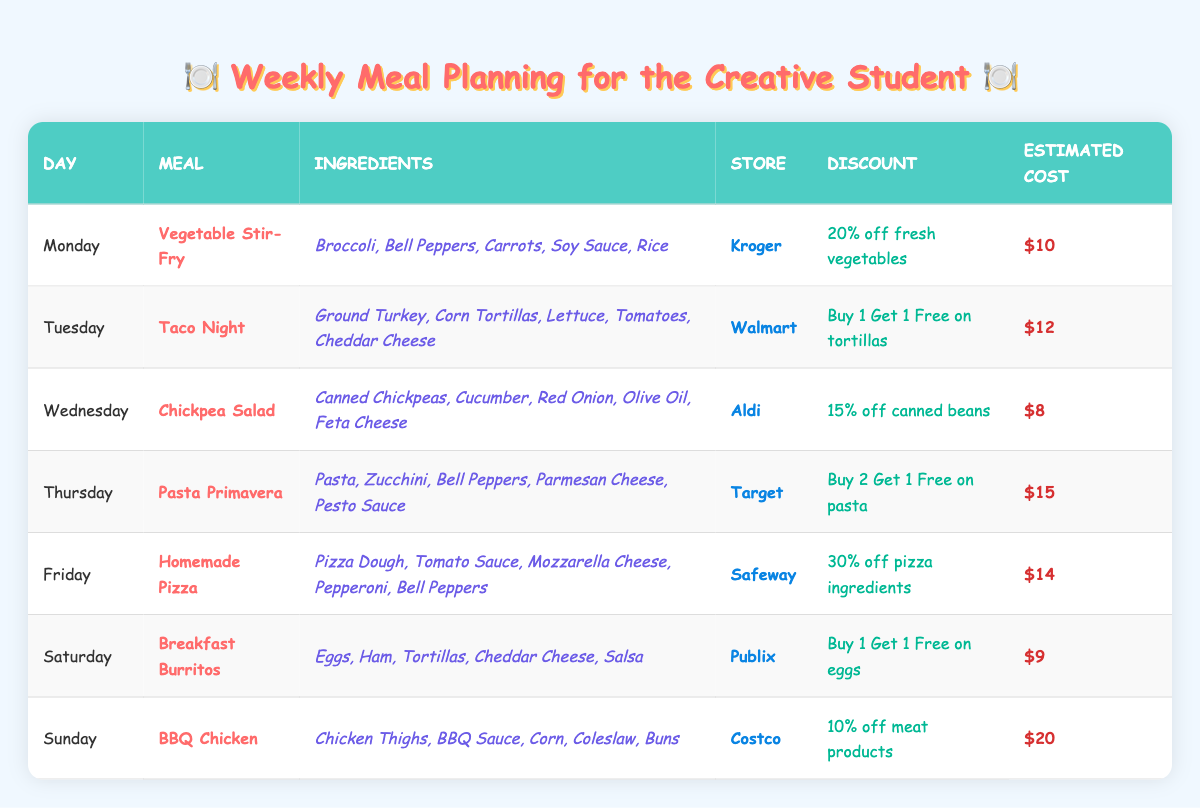What meal is planned for Wednesday? The table lists the meal for Wednesday as "Chickpea Salad."
Answer: Chickpea Salad Which store offers a discount on taco ingredients? The table shows that Walmart offers a "Buy 1 Get 1 Free on tortillas" discount for Taco Night.
Answer: Walmart What is the estimated cost of the Vegetable Stir-Fry? The table provides the estimated cost for the Vegetable Stir-Fry as "$10."
Answer: $10 Which day's meal has the highest estimated cost? The meals' estimated costs are $10 (Monday), $12 (Tuesday), $8 (Wednesday), $15 (Thursday), $14 (Friday), $9 (Saturday), and $20 (Sunday). The highest is on Sunday for BBQ Chicken at $20.
Answer: $20 Did Aldi offer any discounts on the Chickpea Salad ingredients? Yes, Aldi provided a "15% off canned beans" discount for the ingredients needed for the Chickpea Salad.
Answer: Yes What are the main ingredients for the Homemade Pizza on Friday? The table lists the ingredients for Homemade Pizza as Pizza Dough, Tomato Sauce, Mozzarella Cheese, Pepperoni, and Bell Peppers.
Answer: Pizza Dough, Tomato Sauce, Mozzarella Cheese, Pepperoni, Bell Peppers What is the average estimated cost of the meals from Monday to Saturday? The estimated costs for Monday ($10), Tuesday ($12), Wednesday ($8), Thursday ($15), Friday ($14), and Saturday ($9) sum to $68. There are 6 days, so the average is $68 / 6 = $11.33.
Answer: $11.33 Are there any meals that include tortillas in their ingredients? Yes, Taco Night on Tuesday and Breakfast Burritos on Saturday both include tortillas in their ingredients.
Answer: Yes Which meal has a discount of 30%? The table indicates that Homemade Pizza has a discount of "30% off pizza ingredients."
Answer: Homemade Pizza If I wanted to make Pasta Primavera on Thursday, what discount could I apply? The table states that the discount for Pasta Primavera ingredients at Target is "Buy 2 Get 1 Free on pasta."
Answer: Buy 2 Get 1 Free on pasta 